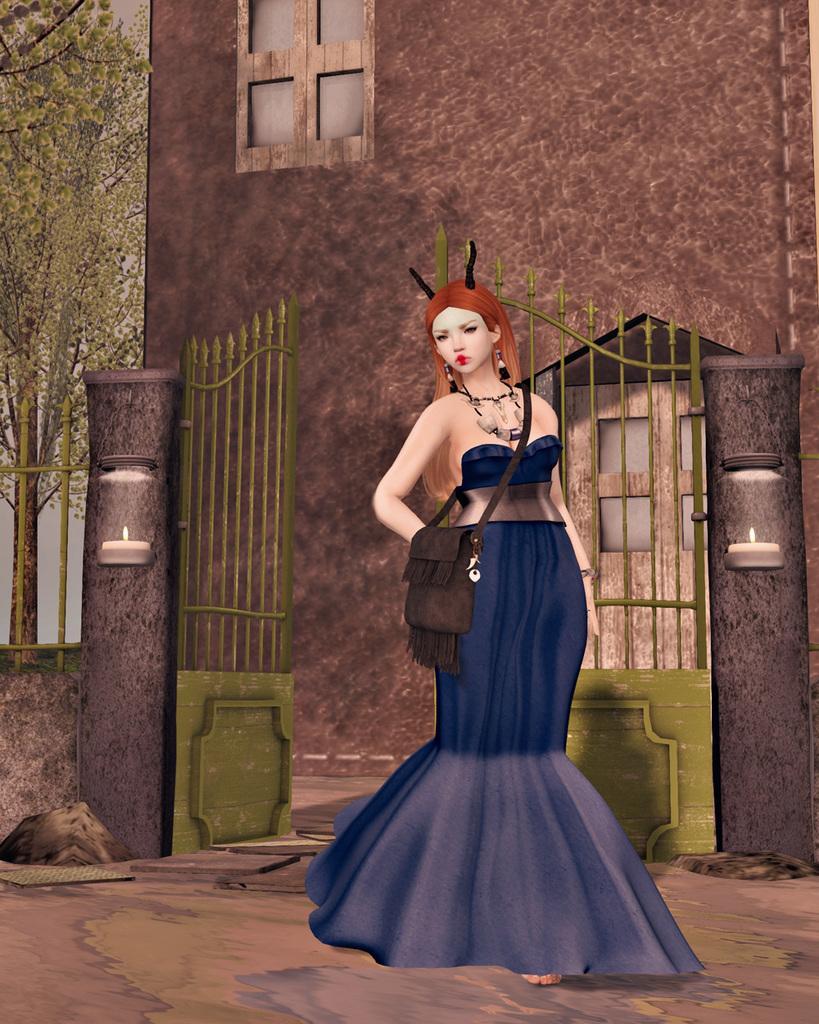How would you summarize this image in a sentence or two? This is an animated image. In which we can see a woman wearing a blue dress. At the bottom, there is ground. In the background, we can see a gate and a building. On the left, there is a tree. 